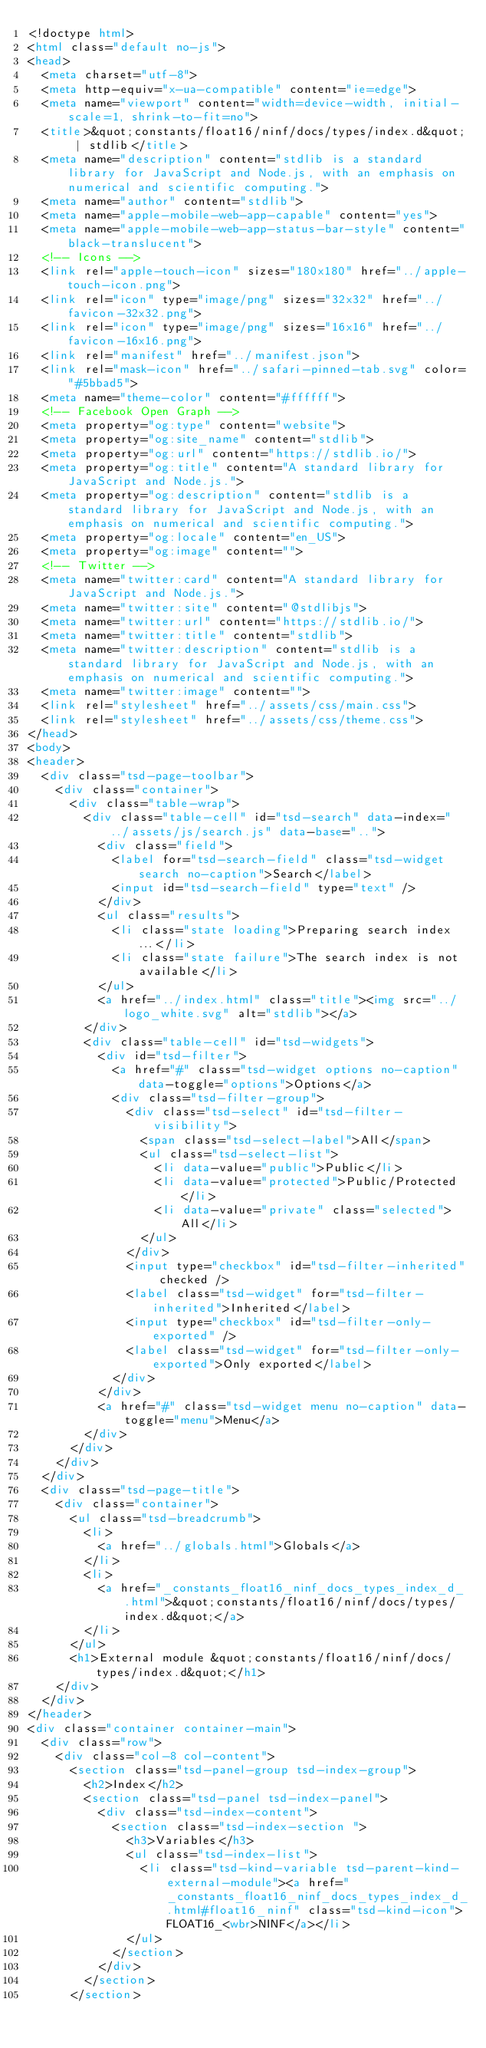Convert code to text. <code><loc_0><loc_0><loc_500><loc_500><_HTML_><!doctype html>
<html class="default no-js">
<head>
	<meta charset="utf-8">
	<meta http-equiv="x-ua-compatible" content="ie=edge">
	<meta name="viewport" content="width=device-width, initial-scale=1, shrink-to-fit=no">
	<title>&quot;constants/float16/ninf/docs/types/index.d&quot; | stdlib</title>
	<meta name="description" content="stdlib is a standard library for JavaScript and Node.js, with an emphasis on numerical and scientific computing.">
	<meta name="author" content="stdlib">
	<meta name="apple-mobile-web-app-capable" content="yes">
	<meta name="apple-mobile-web-app-status-bar-style" content="black-translucent">
	<!-- Icons -->
	<link rel="apple-touch-icon" sizes="180x180" href="../apple-touch-icon.png">
	<link rel="icon" type="image/png" sizes="32x32" href="../favicon-32x32.png">
	<link rel="icon" type="image/png" sizes="16x16" href="../favicon-16x16.png">
	<link rel="manifest" href="../manifest.json">
	<link rel="mask-icon" href="../safari-pinned-tab.svg" color="#5bbad5">
	<meta name="theme-color" content="#ffffff">
	<!-- Facebook Open Graph -->
	<meta property="og:type" content="website">
	<meta property="og:site_name" content="stdlib">
	<meta property="og:url" content="https://stdlib.io/">
	<meta property="og:title" content="A standard library for JavaScript and Node.js.">
	<meta property="og:description" content="stdlib is a standard library for JavaScript and Node.js, with an emphasis on numerical and scientific computing.">
	<meta property="og:locale" content="en_US">
	<meta property="og:image" content="">
	<!-- Twitter -->
	<meta name="twitter:card" content="A standard library for JavaScript and Node.js.">
	<meta name="twitter:site" content="@stdlibjs">
	<meta name="twitter:url" content="https://stdlib.io/">
	<meta name="twitter:title" content="stdlib">
	<meta name="twitter:description" content="stdlib is a standard library for JavaScript and Node.js, with an emphasis on numerical and scientific computing.">
	<meta name="twitter:image" content="">
	<link rel="stylesheet" href="../assets/css/main.css">
	<link rel="stylesheet" href="../assets/css/theme.css">
</head>
<body>
<header>
	<div class="tsd-page-toolbar">
		<div class="container">
			<div class="table-wrap">
				<div class="table-cell" id="tsd-search" data-index="../assets/js/search.js" data-base="..">
					<div class="field">
						<label for="tsd-search-field" class="tsd-widget search no-caption">Search</label>
						<input id="tsd-search-field" type="text" />
					</div>
					<ul class="results">
						<li class="state loading">Preparing search index...</li>
						<li class="state failure">The search index is not available</li>
					</ul>
					<a href="../index.html" class="title"><img src="../logo_white.svg" alt="stdlib"></a>
				</div>
				<div class="table-cell" id="tsd-widgets">
					<div id="tsd-filter">
						<a href="#" class="tsd-widget options no-caption" data-toggle="options">Options</a>
						<div class="tsd-filter-group">
							<div class="tsd-select" id="tsd-filter-visibility">
								<span class="tsd-select-label">All</span>
								<ul class="tsd-select-list">
									<li data-value="public">Public</li>
									<li data-value="protected">Public/Protected</li>
									<li data-value="private" class="selected">All</li>
								</ul>
							</div>
							<input type="checkbox" id="tsd-filter-inherited" checked />
							<label class="tsd-widget" for="tsd-filter-inherited">Inherited</label>
							<input type="checkbox" id="tsd-filter-only-exported" />
							<label class="tsd-widget" for="tsd-filter-only-exported">Only exported</label>
						</div>
					</div>
					<a href="#" class="tsd-widget menu no-caption" data-toggle="menu">Menu</a>
				</div>
			</div>
		</div>
	</div>
	<div class="tsd-page-title">
		<div class="container">
			<ul class="tsd-breadcrumb">
				<li>
					<a href="../globals.html">Globals</a>
				</li>
				<li>
					<a href="_constants_float16_ninf_docs_types_index_d_.html">&quot;constants/float16/ninf/docs/types/index.d&quot;</a>
				</li>
			</ul>
			<h1>External module &quot;constants/float16/ninf/docs/types/index.d&quot;</h1>
		</div>
	</div>
</header>
<div class="container container-main">
	<div class="row">
		<div class="col-8 col-content">
			<section class="tsd-panel-group tsd-index-group">
				<h2>Index</h2>
				<section class="tsd-panel tsd-index-panel">
					<div class="tsd-index-content">
						<section class="tsd-index-section ">
							<h3>Variables</h3>
							<ul class="tsd-index-list">
								<li class="tsd-kind-variable tsd-parent-kind-external-module"><a href="_constants_float16_ninf_docs_types_index_d_.html#float16_ninf" class="tsd-kind-icon">FLOAT16_<wbr>NINF</a></li>
							</ul>
						</section>
					</div>
				</section>
			</section></code> 